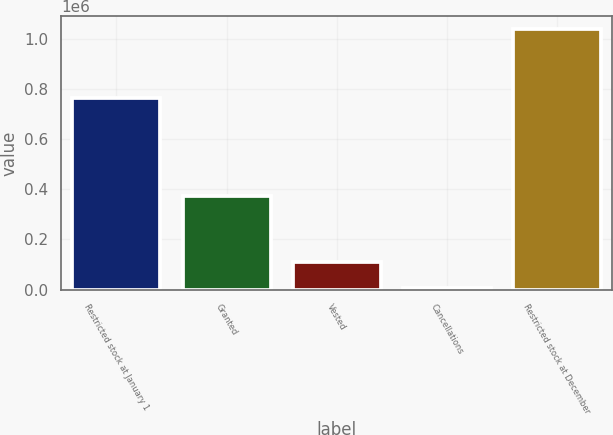<chart> <loc_0><loc_0><loc_500><loc_500><bar_chart><fcel>Restricted stock at January 1<fcel>Granted<fcel>Vested<fcel>Cancellations<fcel>Restricted stock at December<nl><fcel>764705<fcel>374455<fcel>108232<fcel>4895<fcel>1.03827e+06<nl></chart> 